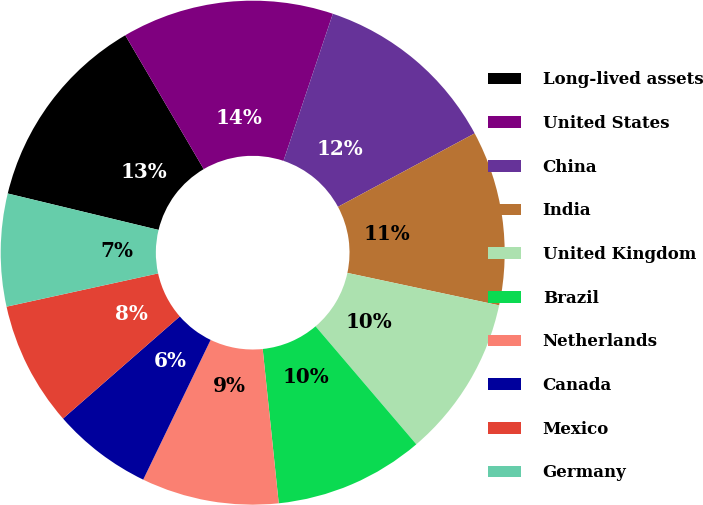Convert chart. <chart><loc_0><loc_0><loc_500><loc_500><pie_chart><fcel>Long-lived assets<fcel>United States<fcel>China<fcel>India<fcel>United Kingdom<fcel>Brazil<fcel>Netherlands<fcel>Canada<fcel>Mexico<fcel>Germany<nl><fcel>12.79%<fcel>13.59%<fcel>12.0%<fcel>11.2%<fcel>10.4%<fcel>9.6%<fcel>8.8%<fcel>6.41%<fcel>8.0%<fcel>7.21%<nl></chart> 